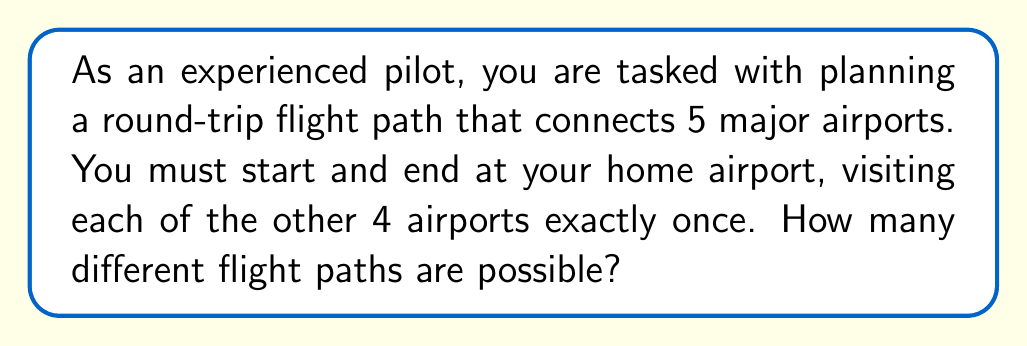Provide a solution to this math problem. Let's approach this step-by-step:

1) This problem is a variation of the Traveling Salesman Problem, where we need to find the number of possible routes visiting each location once and returning to the starting point.

2) We have 5 airports in total, but the starting/ending airport is fixed. So, we need to arrange the other 4 airports.

3) The number of ways to arrange 4 airports is a straightforward permutation:

   $$P(4,4) = 4! = 4 \times 3 \times 2 \times 1 = 24$$

4) However, there's a catch. In this case, the direction of travel doesn't matter. For example, the path A → B → C → D → A is considered the same as A → D → C → B → A (just reversed).

5) This means that for each unique path, we've counted its reverse as well. To correct for this, we need to divide our total by 2:

   $$\text{Number of unique paths} = \frac{4!}{2} = \frac{24}{2} = 12$$

Therefore, there are 12 different possible flight paths.
Answer: 12 